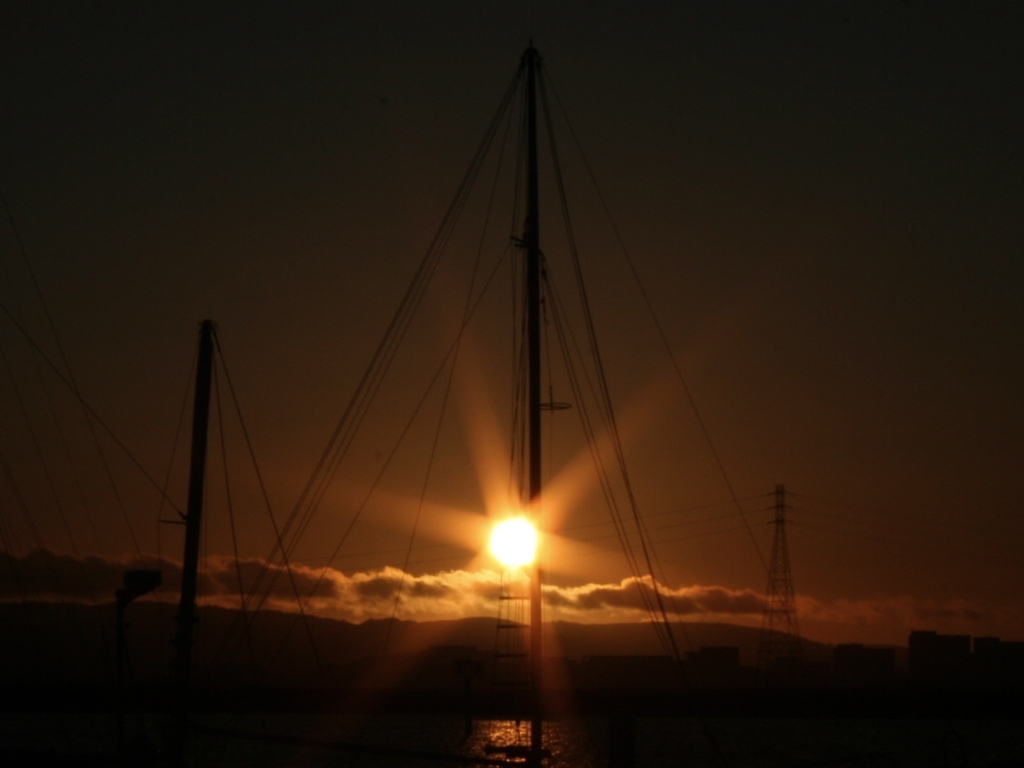Does the image suffer from any distortion issues? The image demonstrates a high contrast between the dark foreground and the bright sunset, making it hard to discern fine details. However, there is no apparent technical distortion such as pixelation or warping; the quality seems intentional to set a mood rather than a flaw. 